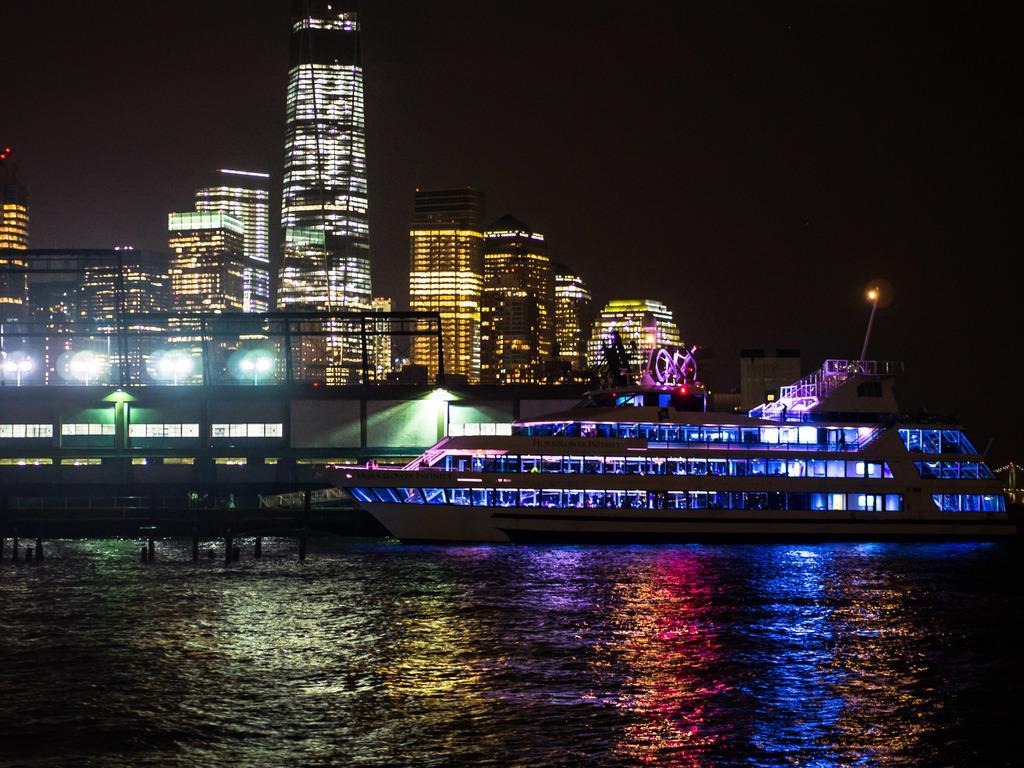In one or two sentences, can you explain what this image depicts? In this image I can see the ship on the water. To the right I can see few more ships. In the background there are buildings and the sky. 